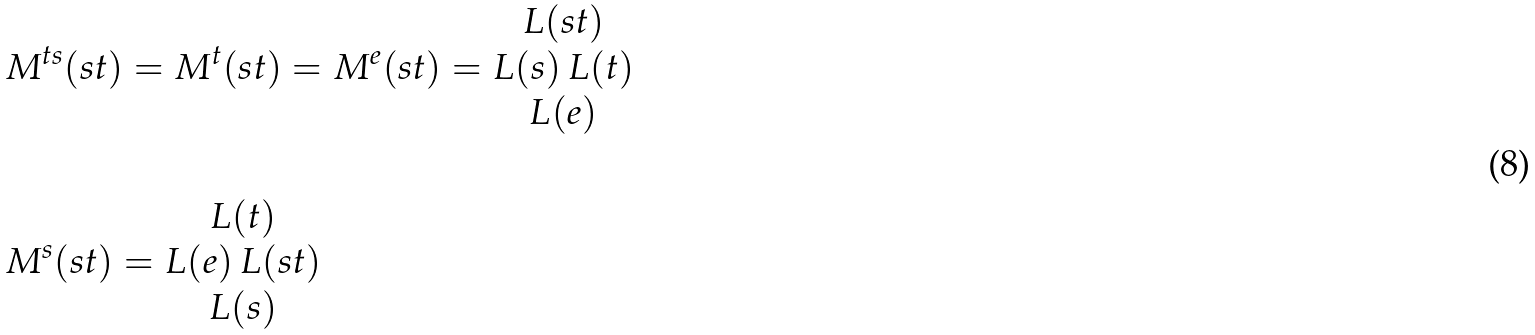<formula> <loc_0><loc_0><loc_500><loc_500>& M ^ { t s } ( s t ) = M ^ { t } ( s t ) = M ^ { e } ( s t ) = \begin{matrix} L ( s t ) \\ L ( s ) \, L ( t ) \\ L ( e ) \end{matrix} \\ & \\ & M ^ { s } ( s t ) = \begin{matrix} L ( t ) \\ L ( e ) \, L ( s t ) \\ L ( s ) \end{matrix}</formula> 